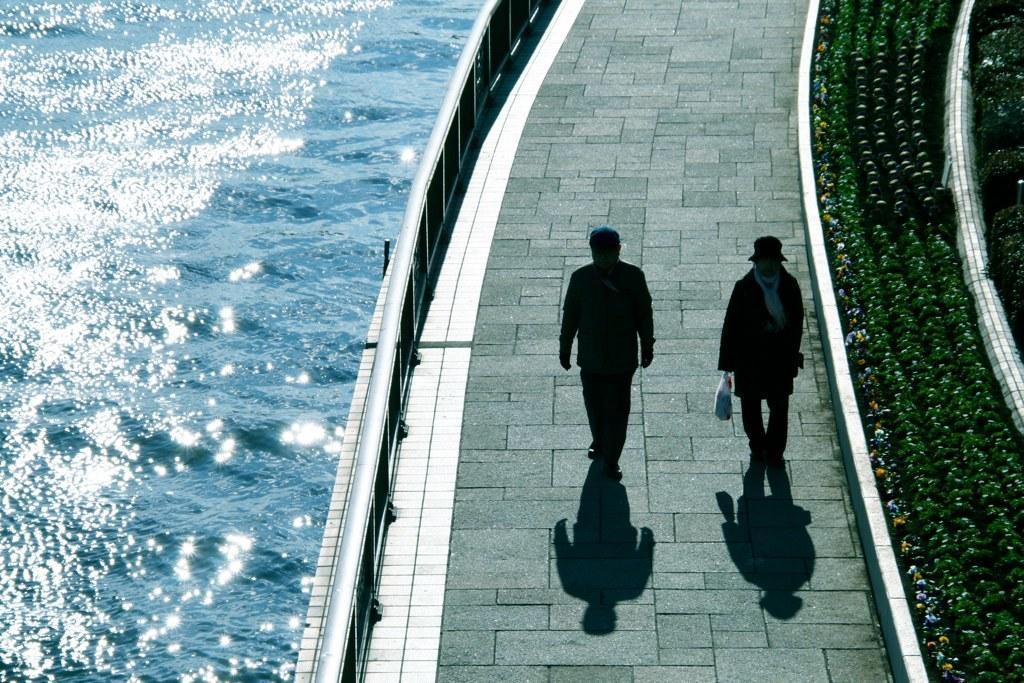Describe this image in one or two sentences. In this image, I can see two people walking on the pathway. These are the plants. I can see the water flowing. These are the kind of barricades. 